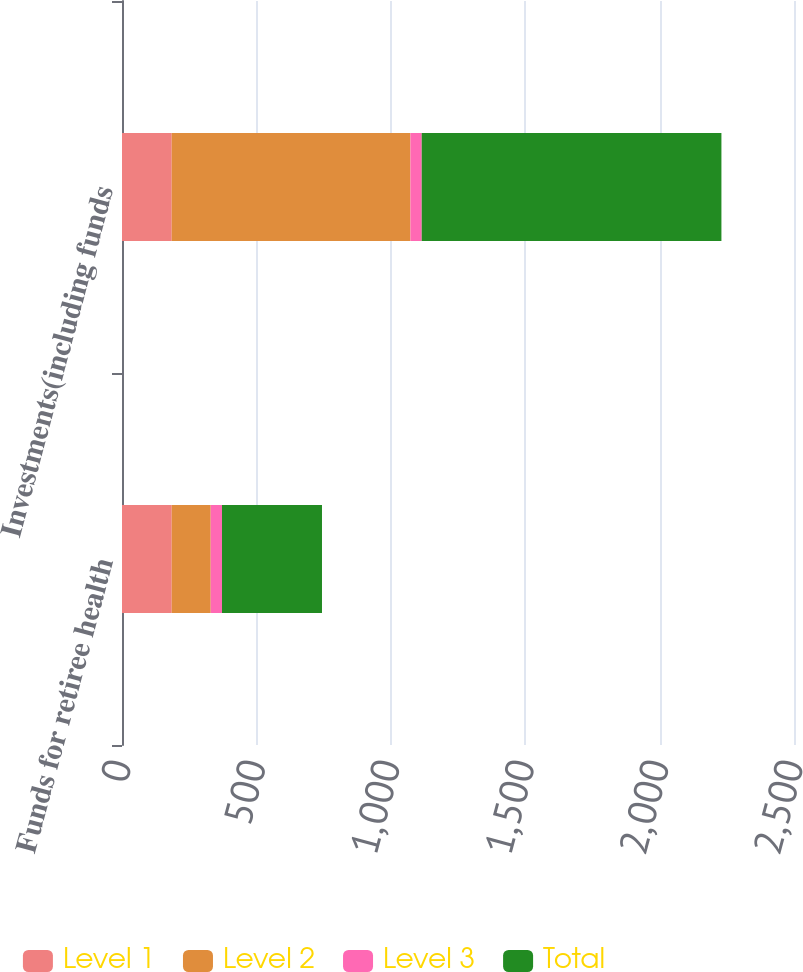Convert chart. <chart><loc_0><loc_0><loc_500><loc_500><stacked_bar_chart><ecel><fcel>Funds for retiree health<fcel>Investments(including funds<nl><fcel>Level 1<fcel>185<fcel>185<nl><fcel>Level 2<fcel>145<fcel>888<nl><fcel>Level 3<fcel>42<fcel>42<nl><fcel>Total<fcel>372<fcel>1115<nl></chart> 